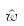Convert formula to latex. <formula><loc_0><loc_0><loc_500><loc_500>\hat { w }</formula> 